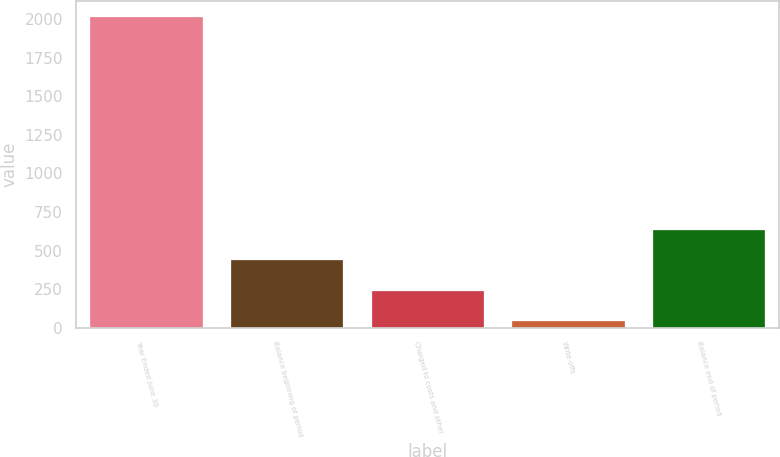<chart> <loc_0><loc_0><loc_500><loc_500><bar_chart><fcel>Year Ended June 30<fcel>Balance beginning of period<fcel>Charged to costs and other<fcel>Write-offs<fcel>Balance end of period<nl><fcel>2015<fcel>437.4<fcel>240.2<fcel>43<fcel>634.6<nl></chart> 